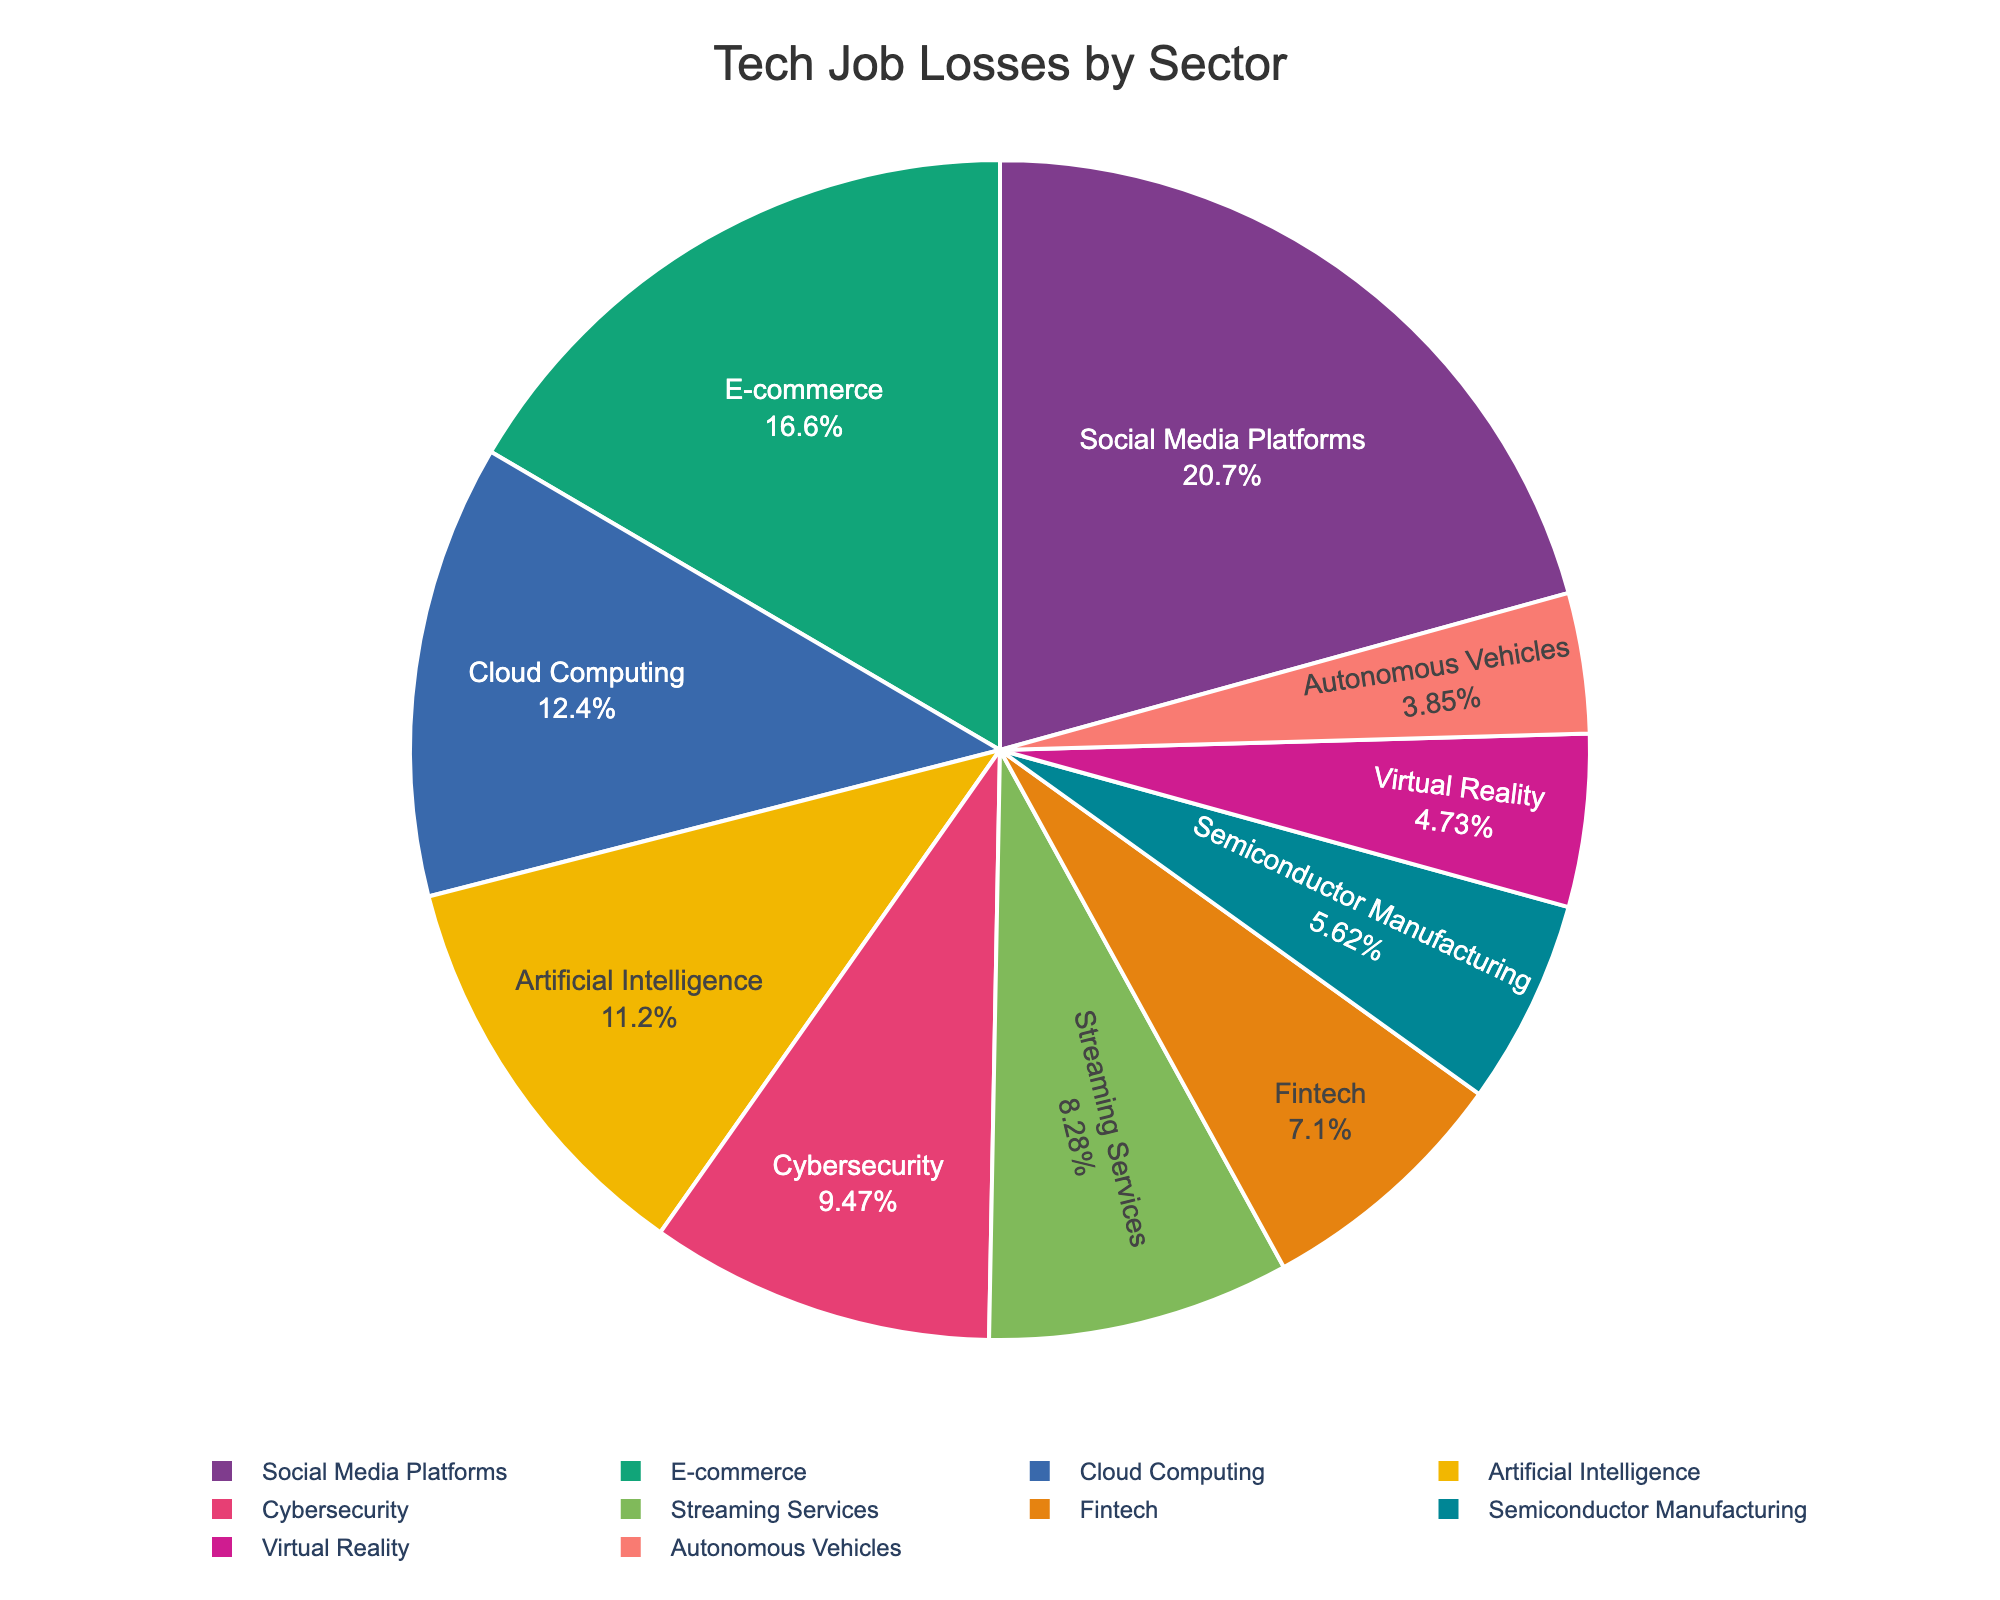Which sector experienced the highest number of job losses? Social Media Platforms have a slice that leads over others, signifying the highest number of job losses.
Answer: Social Media Platforms What is the total number of job losses in the E-commerce and Cloud Computing sectors combined? E-commerce job losses are 2800 and Cloud Computing job losses are 2100. Adding these together gives 2800 + 2100 = 4900.
Answer: 4900 How do job losses in Artificial Intelligence compare to those in Cybersecurity? The job losses in Artificial Intelligence are 1900, while Cybersecurity has 1600. Artificial Intelligence experienced more job losses.
Answer: Artificial Intelligence Which sector has fewer job losses: Fintech or Semiconductor Manufacturing? The job losses in Fintech are 1200, while in Semiconductor Manufacturing they are 950. Semiconductor Manufacturing has fewer job losses.
Answer: Semiconductor Manufacturing What percentage of the total job losses did the Streaming Services sector account for? The pie chart shows the percentage inside each slice. Streaming Services accounted for 1400 job losses. We need to find this percentage out of the total. The total number of job losses is 3500 + 2800 + 2100 + 1900 + 1600 + 1400 + 1200 + 950 + 800 + 650 = 17400. Therefore, (1400/17400) * 100 ≈ 8%.
Answer: 8% Compare the job losses between the Virtual Reality and Autonomous Vehicles sectors. Virtual Reality experienced 800 job losses, while Autonomous Vehicles had 650. Virtual Reality has more job losses.
Answer: Virtual Reality What is the overall difference in job losses between the Social Media Platforms and Fintech sectors? Social Media Platforms have 3500 job losses and Fintech has 1200. The difference is 3500 - 1200 = 2300.
Answer: 2300 What are the combined job losses in the Cybersecurity, Streaming Services, and Fintech sectors? Adding job losses in Cybersecurity (1600), Streaming Services (1400), and Fintech (1200) gives us 1600 + 1400 + 1200 = 4200.
Answer: 4200 If you sum the job losses from Cloud Computing, Cybersecurity, and Virtual Reality, does the total exceed the losses in E-commerce? Cloud Computing has 2100, Cybersecurity has 1600, and Virtual Reality has 800. Summing these gives 2100 + 1600 + 800 = 4500. Comparing this to E-commerce, which has 2800, 4500 is greater than 2800.
Answer: Yes How much larger are the job losses in Social Media Platforms compared to Artificial Intelligence? Social Media Platforms have 3500 job losses, whereas Artificial Intelligence has 1900. The difference is 3500 - 1900 = 1600.
Answer: 1600 